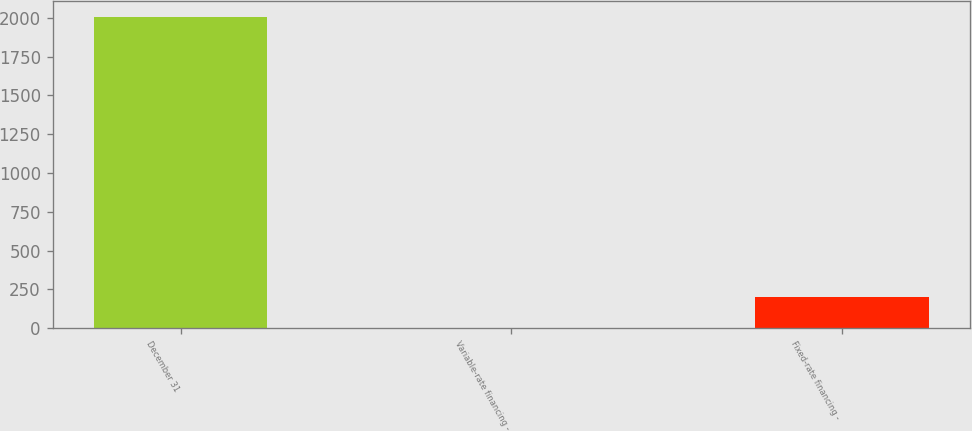Convert chart to OTSL. <chart><loc_0><loc_0><loc_500><loc_500><bar_chart><fcel>December 31<fcel>Variable-rate financing -<fcel>Fixed-rate financing -<nl><fcel>2007<fcel>2<fcel>202.5<nl></chart> 